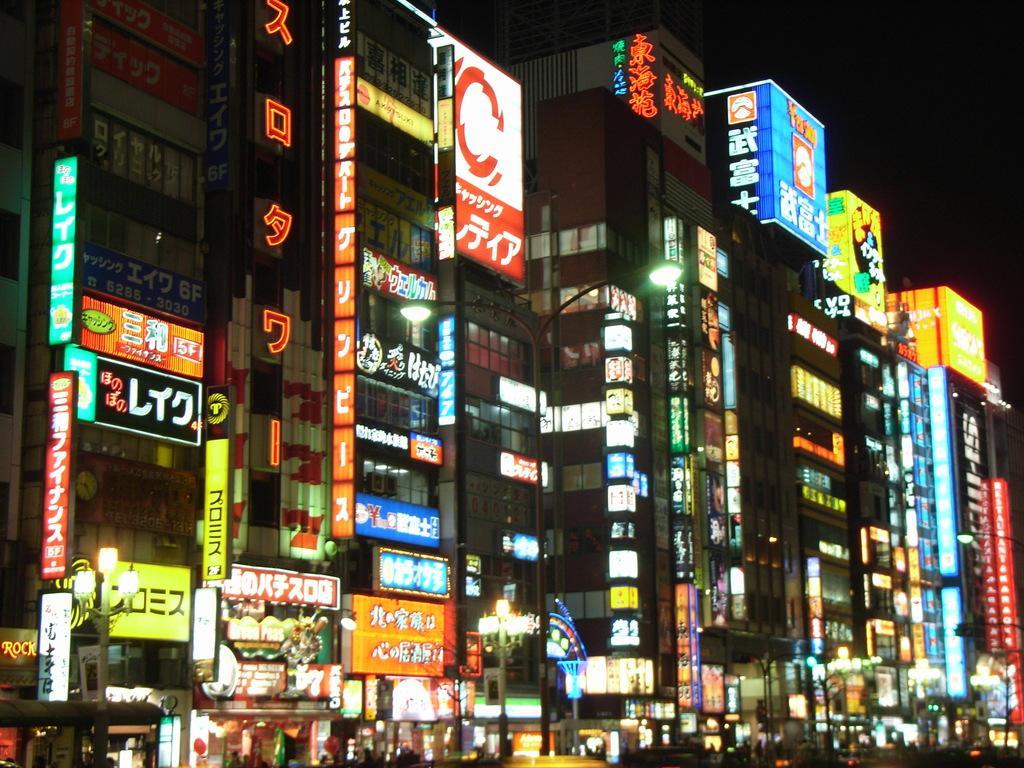How would you summarize this image in a sentence or two? This is the picture of a city. In this image there are buildings and there are hoardings on the buildings. At the bottom there are trees and poles and there are group of people. At the top there is sky. 